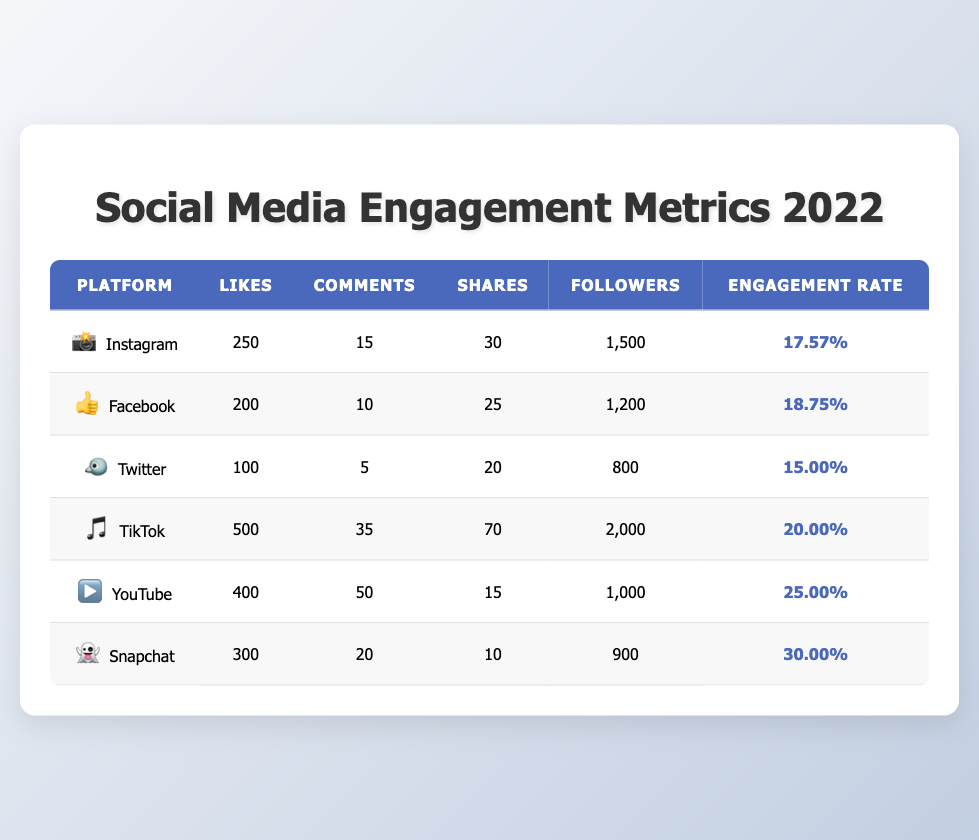What is the engagement rate for TikTok? The table lists TikTok's engagement rate directly under the "Engagement Rate" column. It shows an engagement rate of 20.00%.
Answer: 20.00% Which platform has the highest number of likes per post? By comparing the "Likes" column for all platforms, TikTok has the highest likes per video at 500 compared to other platforms.
Answer: TikTok What is the total number of likes for Instagram and YouTube combined? To find this, add likes from both platforms: Instagram has 250 likes and YouTube has 400 likes. So, the total is 250 + 400 = 650.
Answer: 650 Is Snapchat's engagement rate higher than Twitter's? The engagement rate for Snapchat is 30.00% and for Twitter, it's 15.00%. Therefore, Snapchat's engagement rate is indeed higher.
Answer: Yes What is the average comments per post across all platforms? First, sum the comments: Instagram (15) + Facebook (10) + Twitter (5) + TikTok (35) + YouTube (50) + Snapchat (20) = 135. Then, divide by the number of platforms (6): 135 / 6 = 22.5.
Answer: 22.5 Which platform has the lowest number of shares? Looking at the "Shares" column, the lowest value is from Snapchat with 10 shares per story.
Answer: Snapchat Are there any platforms with an engagement rate above 25%? Checking the engagement rates, only YouTube (25.00%) and Snapchat (30.00%) have rates at or above 25%. Yes, they meet the criteria.
Answer: Yes What is the difference in followers between TikTok and Facebook? TikTok has 2000 followers and Facebook has 1200 followers. The difference is calculated by subtracting: 2000 - 1200 = 800 followers.
Answer: 800 